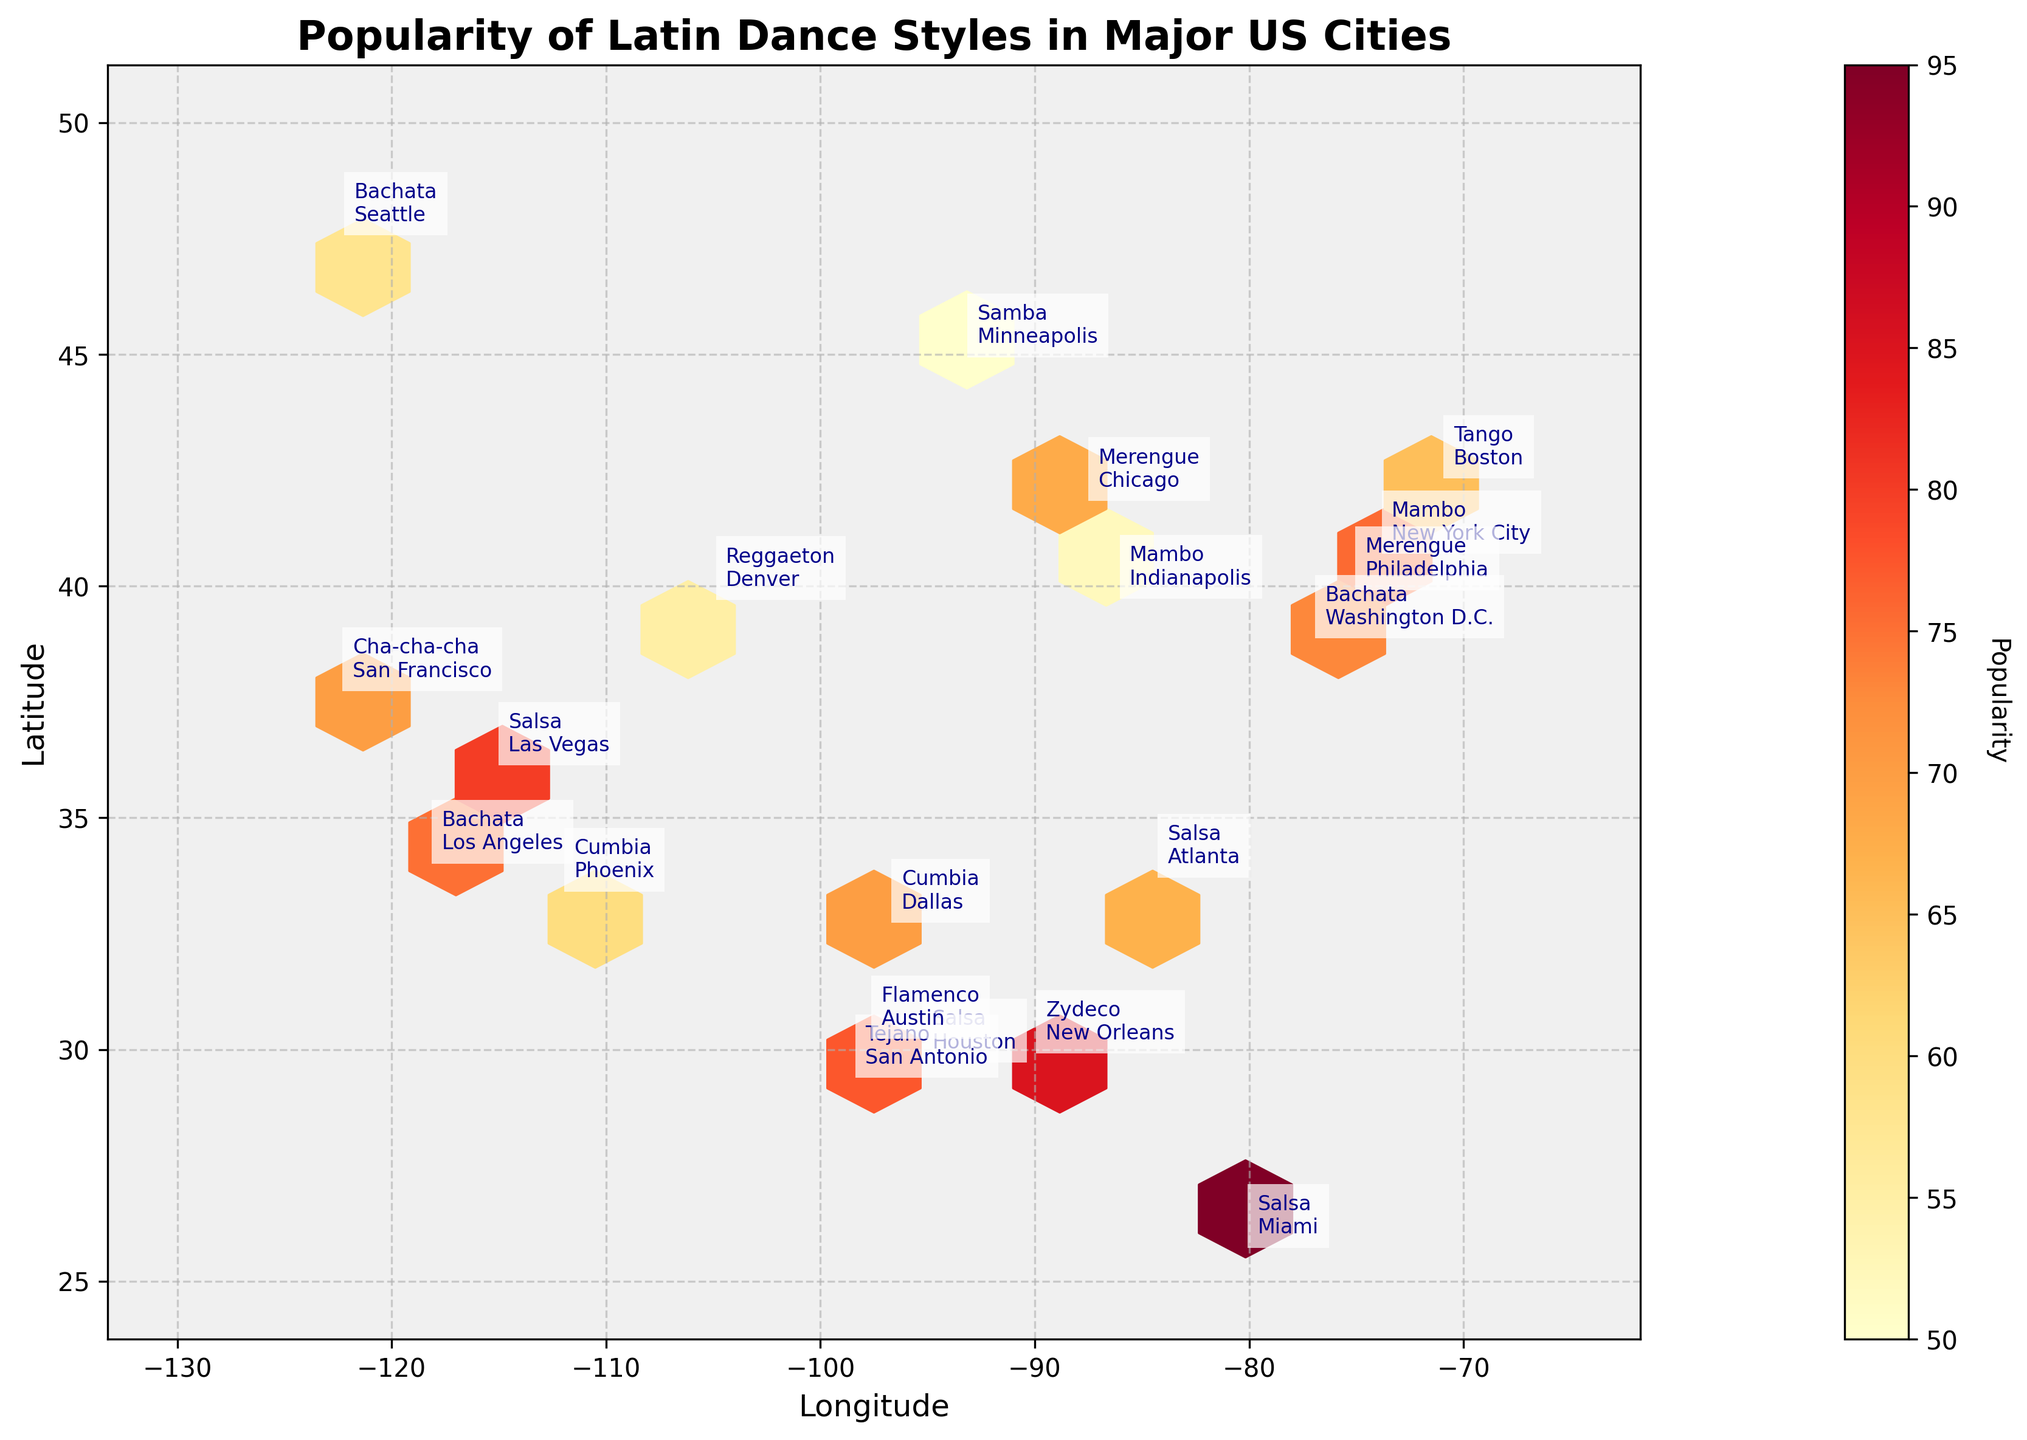what's the title of the figure? The title of the figure is usually displayed at the top. In this case, the title is "Popularity of Latin Dance Styles in Major US Cities".
Answer: Popularity of Latin Dance Styles in Major US Cities How many dance styles are annotated in New York City? Locate New York City on the map by its coordinates and count the number of annotations. New York City has the coordinates (-73.9352, 40.7306), and the annotated dance style is Mambo.
Answer: 1 Which city has the highest popularity for Salsa? Identify the cities with the dance style Salsa and compare their popularity values. Miami has the highest popularity for Salsa with a value of 95.
Answer: Miami What's the average popularity value for the dance styles in the Texas cities? Identify the Texas cities (Houston, San Antonio, Dallas, Austin) and their respective popularity values (82, 78, 70, 72). Sum these values and divide by the number of Texas cities. (82 + 78 + 70 + 72) / 4 = 75.5.
Answer: 75.5 Which dance style is popular in the most western city on the map? Find the city with the westernmost longitude. The most western city on the map is Los Angeles with a longitude of -118.2437, and the popular dance style there is Bachata.
Answer: Bachata Compare the popularity of Reggaeton in Denver and Bachata in Seattle. Which one is more popular? Locate Denver and Seattle based on their coordinates and compare their dance style popularity values. Reggaeton has a value of 55 in Denver, while Bachata has a value of 58 in Seattle. 58 is greater than 55.
Answer: Bachata in Seattle What's the least popular dance style represented on the plot? Identify all dance styles and their popularity values, then determine the minimum value. Samba in Minneapolis has the least popularity value of 50.
Answer: Samba Count the number of cities with a popularity value above 80. Check the popularity values in each annotated city and count how many are above 80 (Miami, New York City, Houston, New Orleans, Las Vegas).
Answer: 5 What's the average popularity of all annotated dance styles in the plot? Sum all the popularity values and divide by the number of cities. Values: 82, 75, 68, 95, 88, 60, 78, 70, 55, 65, 72, 50, 58, 63, 67, 70, 52, 85, 73, 80. The sum is 1326, and there are 20 cities. 1326 / 20 = 66.3.
Answer: 66.3 Which city has a higher popularity for Latin dances, Boston or Indianapolis? Locate Boston and Indianapolis based on their coordinates and compare their dance style popularity values. Boston has a value of 65, and Indianapolis has a value of 52. 65 is greater than 52.
Answer: Boston 